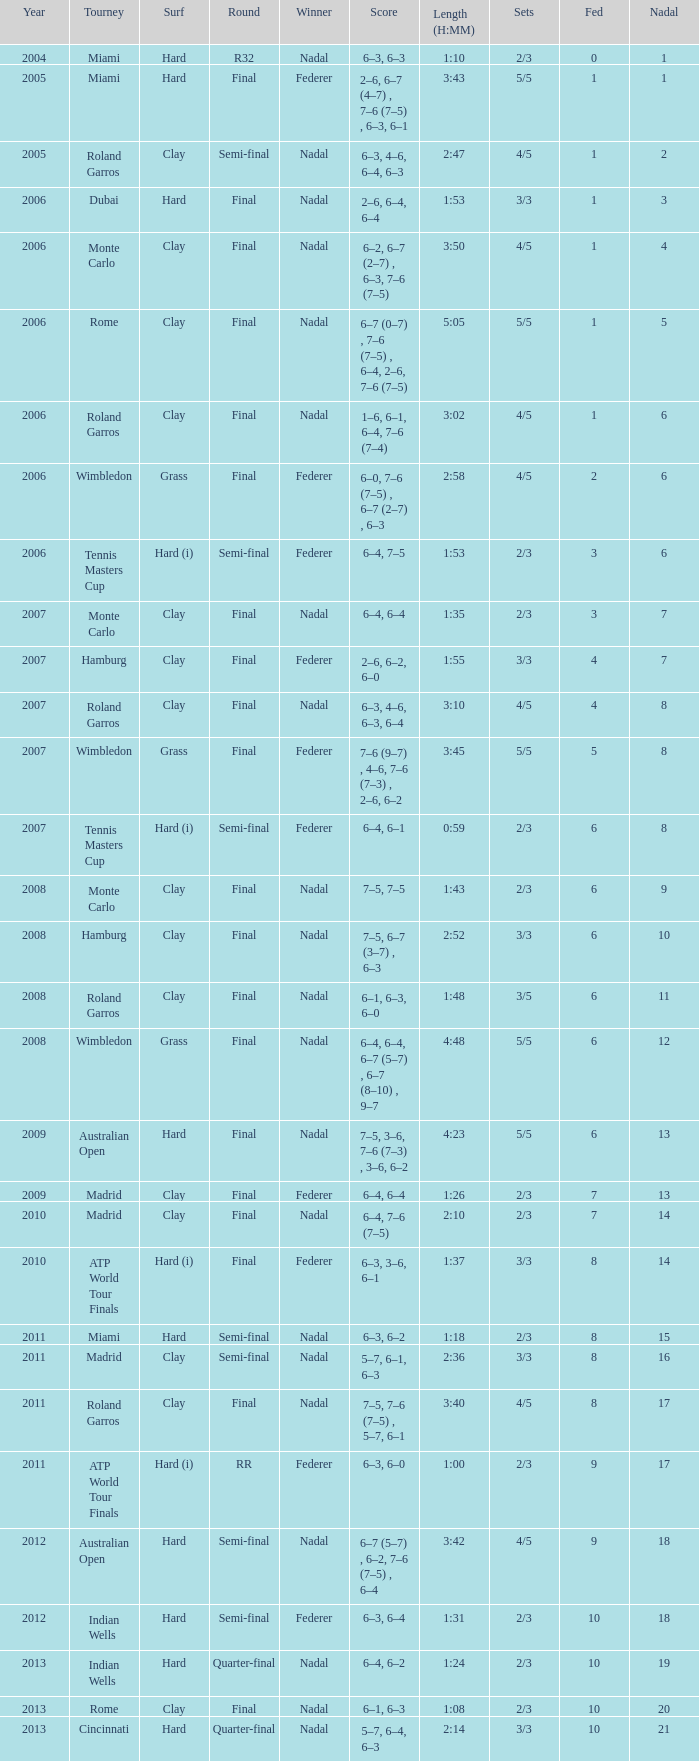Parse the full table. {'header': ['Year', 'Tourney', 'Surf', 'Round', 'Winner', 'Score', 'Length (H:MM)', 'Sets', 'Fed', 'Nadal'], 'rows': [['2004', 'Miami', 'Hard', 'R32', 'Nadal', '6–3, 6–3', '1:10', '2/3', '0', '1'], ['2005', 'Miami', 'Hard', 'Final', 'Federer', '2–6, 6–7 (4–7) , 7–6 (7–5) , 6–3, 6–1', '3:43', '5/5', '1', '1'], ['2005', 'Roland Garros', 'Clay', 'Semi-final', 'Nadal', '6–3, 4–6, 6–4, 6–3', '2:47', '4/5', '1', '2'], ['2006', 'Dubai', 'Hard', 'Final', 'Nadal', '2–6, 6–4, 6–4', '1:53', '3/3', '1', '3'], ['2006', 'Monte Carlo', 'Clay', 'Final', 'Nadal', '6–2, 6–7 (2–7) , 6–3, 7–6 (7–5)', '3:50', '4/5', '1', '4'], ['2006', 'Rome', 'Clay', 'Final', 'Nadal', '6–7 (0–7) , 7–6 (7–5) , 6–4, 2–6, 7–6 (7–5)', '5:05', '5/5', '1', '5'], ['2006', 'Roland Garros', 'Clay', 'Final', 'Nadal', '1–6, 6–1, 6–4, 7–6 (7–4)', '3:02', '4/5', '1', '6'], ['2006', 'Wimbledon', 'Grass', 'Final', 'Federer', '6–0, 7–6 (7–5) , 6–7 (2–7) , 6–3', '2:58', '4/5', '2', '6'], ['2006', 'Tennis Masters Cup', 'Hard (i)', 'Semi-final', 'Federer', '6–4, 7–5', '1:53', '2/3', '3', '6'], ['2007', 'Monte Carlo', 'Clay', 'Final', 'Nadal', '6–4, 6–4', '1:35', '2/3', '3', '7'], ['2007', 'Hamburg', 'Clay', 'Final', 'Federer', '2–6, 6–2, 6–0', '1:55', '3/3', '4', '7'], ['2007', 'Roland Garros', 'Clay', 'Final', 'Nadal', '6–3, 4–6, 6–3, 6–4', '3:10', '4/5', '4', '8'], ['2007', 'Wimbledon', 'Grass', 'Final', 'Federer', '7–6 (9–7) , 4–6, 7–6 (7–3) , 2–6, 6–2', '3:45', '5/5', '5', '8'], ['2007', 'Tennis Masters Cup', 'Hard (i)', 'Semi-final', 'Federer', '6–4, 6–1', '0:59', '2/3', '6', '8'], ['2008', 'Monte Carlo', 'Clay', 'Final', 'Nadal', '7–5, 7–5', '1:43', '2/3', '6', '9'], ['2008', 'Hamburg', 'Clay', 'Final', 'Nadal', '7–5, 6–7 (3–7) , 6–3', '2:52', '3/3', '6', '10'], ['2008', 'Roland Garros', 'Clay', 'Final', 'Nadal', '6–1, 6–3, 6–0', '1:48', '3/5', '6', '11'], ['2008', 'Wimbledon', 'Grass', 'Final', 'Nadal', '6–4, 6–4, 6–7 (5–7) , 6–7 (8–10) , 9–7', '4:48', '5/5', '6', '12'], ['2009', 'Australian Open', 'Hard', 'Final', 'Nadal', '7–5, 3–6, 7–6 (7–3) , 3–6, 6–2', '4:23', '5/5', '6', '13'], ['2009', 'Madrid', 'Clay', 'Final', 'Federer', '6–4, 6–4', '1:26', '2/3', '7', '13'], ['2010', 'Madrid', 'Clay', 'Final', 'Nadal', '6–4, 7–6 (7–5)', '2:10', '2/3', '7', '14'], ['2010', 'ATP World Tour Finals', 'Hard (i)', 'Final', 'Federer', '6–3, 3–6, 6–1', '1:37', '3/3', '8', '14'], ['2011', 'Miami', 'Hard', 'Semi-final', 'Nadal', '6–3, 6–2', '1:18', '2/3', '8', '15'], ['2011', 'Madrid', 'Clay', 'Semi-final', 'Nadal', '5–7, 6–1, 6–3', '2:36', '3/3', '8', '16'], ['2011', 'Roland Garros', 'Clay', 'Final', 'Nadal', '7–5, 7–6 (7–5) , 5–7, 6–1', '3:40', '4/5', '8', '17'], ['2011', 'ATP World Tour Finals', 'Hard (i)', 'RR', 'Federer', '6–3, 6–0', '1:00', '2/3', '9', '17'], ['2012', 'Australian Open', 'Hard', 'Semi-final', 'Nadal', '6–7 (5–7) , 6–2, 7–6 (7–5) , 6–4', '3:42', '4/5', '9', '18'], ['2012', 'Indian Wells', 'Hard', 'Semi-final', 'Federer', '6–3, 6–4', '1:31', '2/3', '10', '18'], ['2013', 'Indian Wells', 'Hard', 'Quarter-final', 'Nadal', '6–4, 6–2', '1:24', '2/3', '10', '19'], ['2013', 'Rome', 'Clay', 'Final', 'Nadal', '6–1, 6–3', '1:08', '2/3', '10', '20'], ['2013', 'Cincinnati', 'Hard', 'Quarter-final', 'Nadal', '5–7, 6–4, 6–3', '2:14', '3/3', '10', '21']]} What were the sets when Federer had 6 and a nadal of 13? 5/5. 